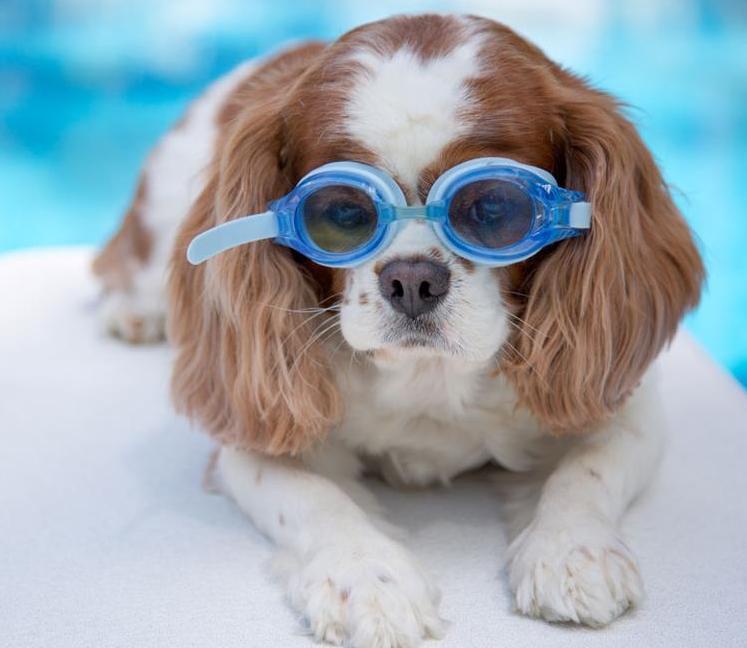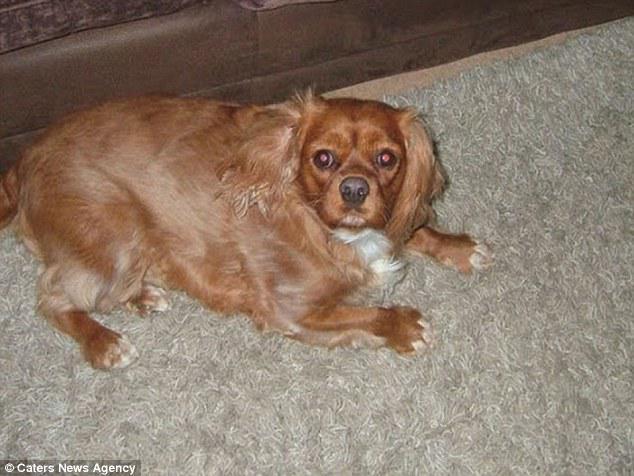The first image is the image on the left, the second image is the image on the right. Given the left and right images, does the statement "There are exactly two dogs in the left image." hold true? Answer yes or no. No. The first image is the image on the left, the second image is the image on the right. For the images displayed, is the sentence "One image contains a brown-and-white spaniel next to a dog with darker markings, and the other image contains only one brown-and-white spaniel." factually correct? Answer yes or no. No. 